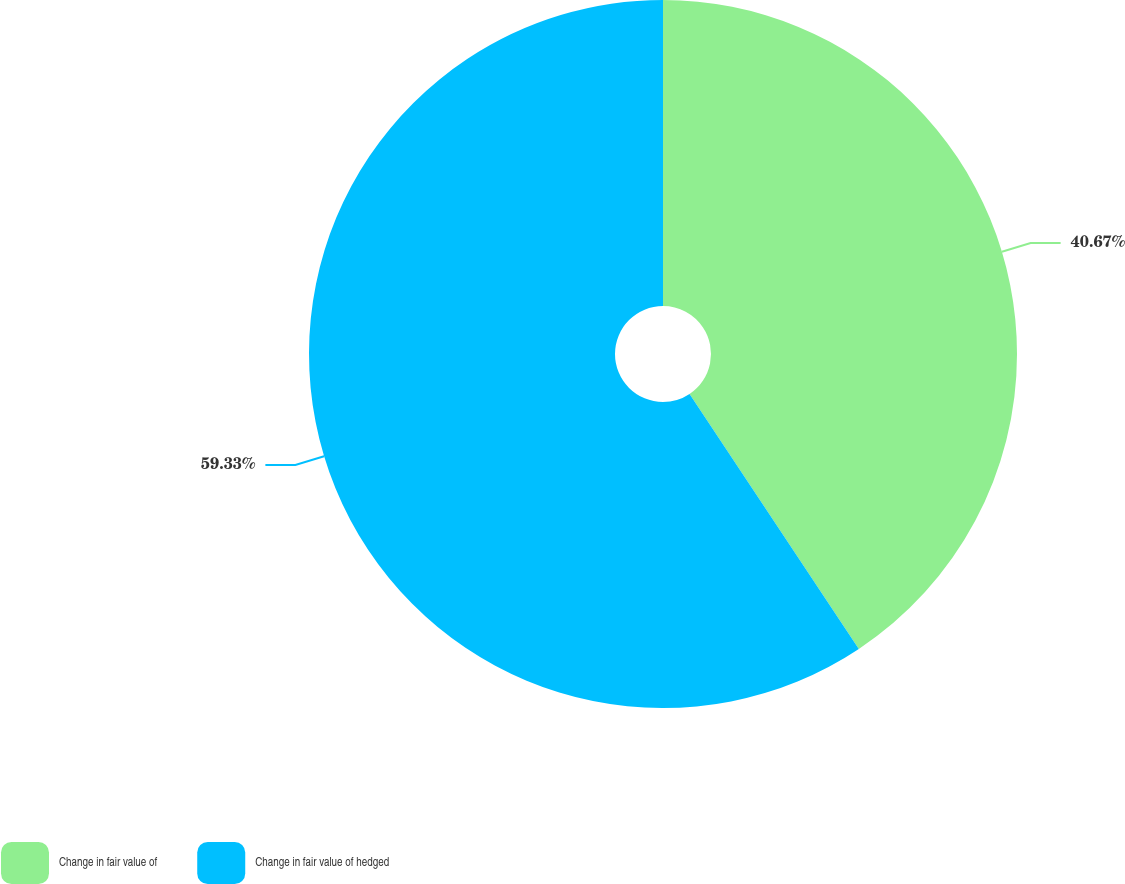Convert chart. <chart><loc_0><loc_0><loc_500><loc_500><pie_chart><fcel>Change in fair value of<fcel>Change in fair value of hedged<nl><fcel>40.67%<fcel>59.33%<nl></chart> 